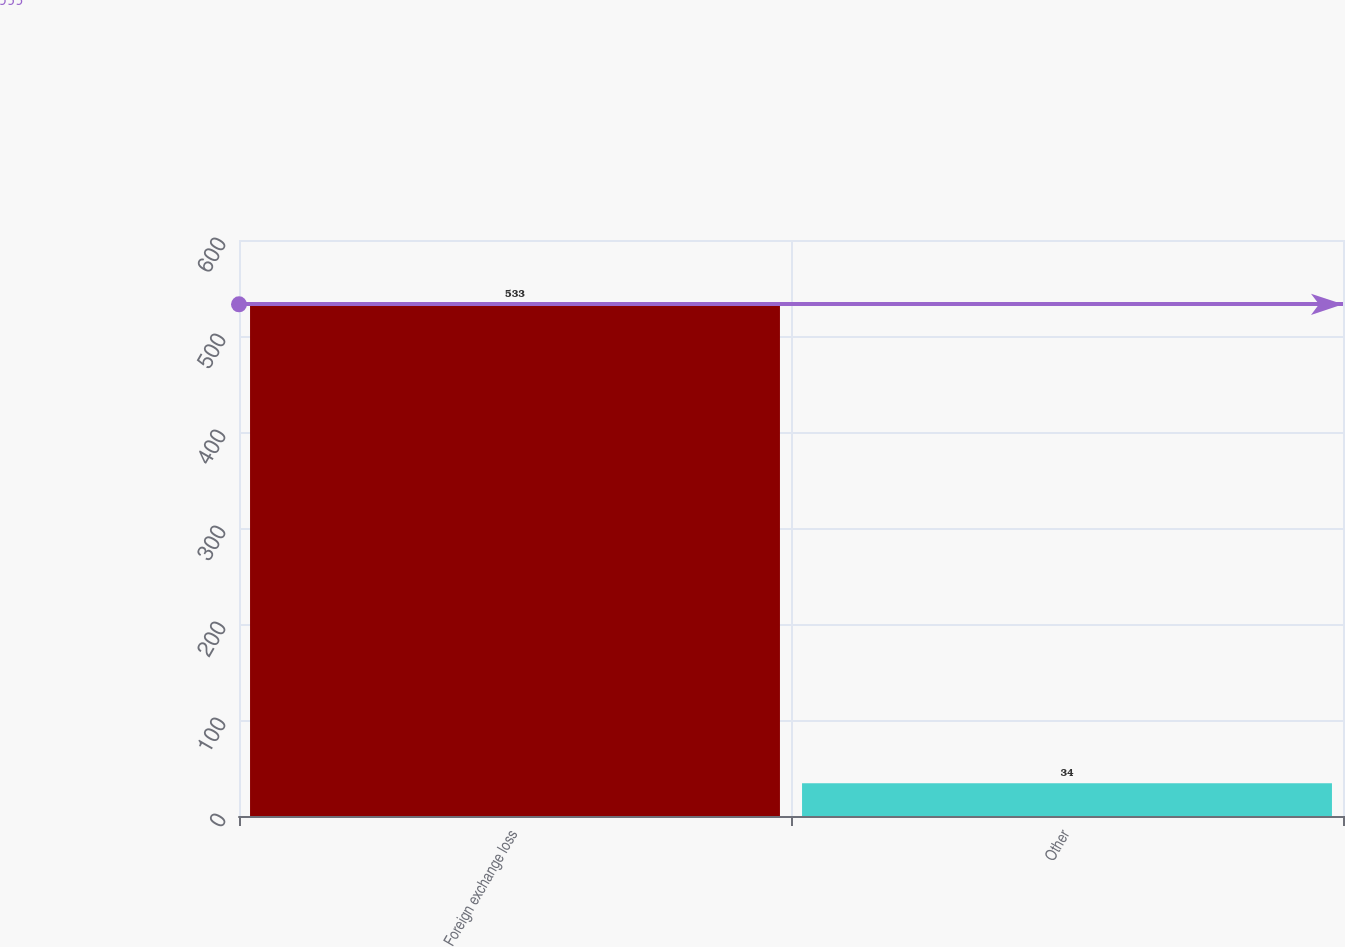Convert chart to OTSL. <chart><loc_0><loc_0><loc_500><loc_500><bar_chart><fcel>Foreign exchange loss<fcel>Other<nl><fcel>533<fcel>34<nl></chart> 